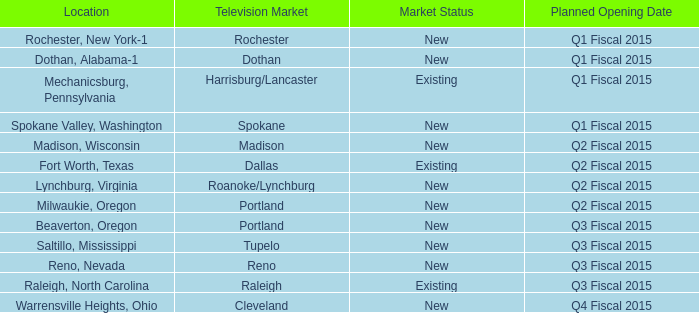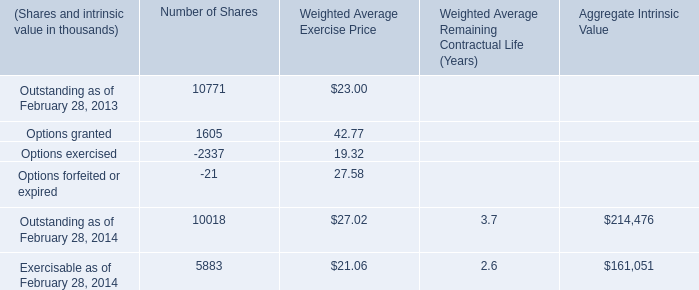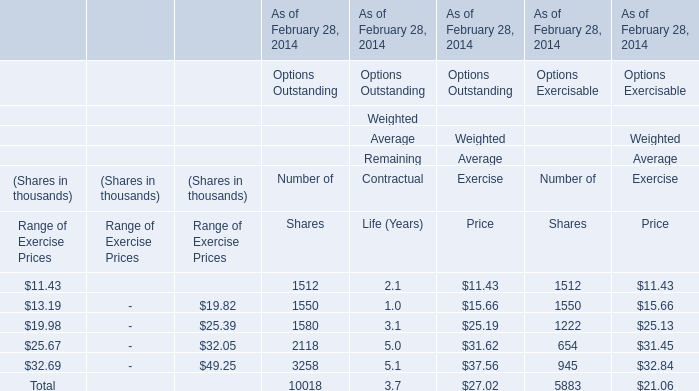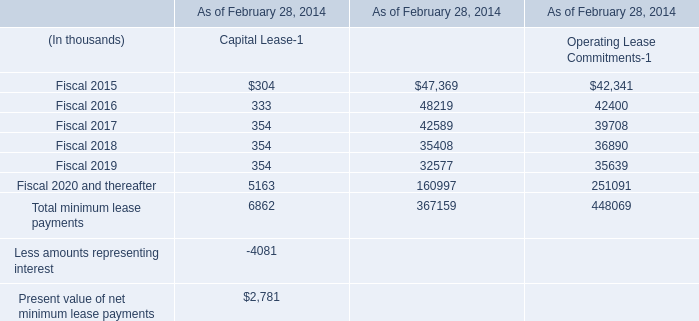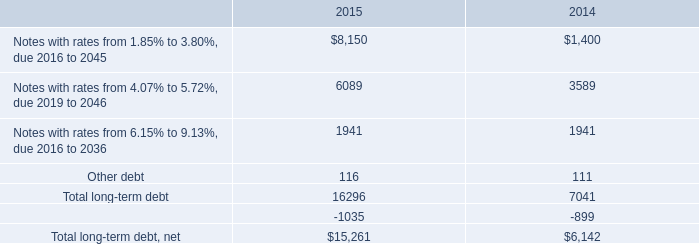what was the percentage change in total long-term debt net from 2014 to 2015? 
Computations: ((15261 - 6142) / 6142)
Answer: 1.4847. 